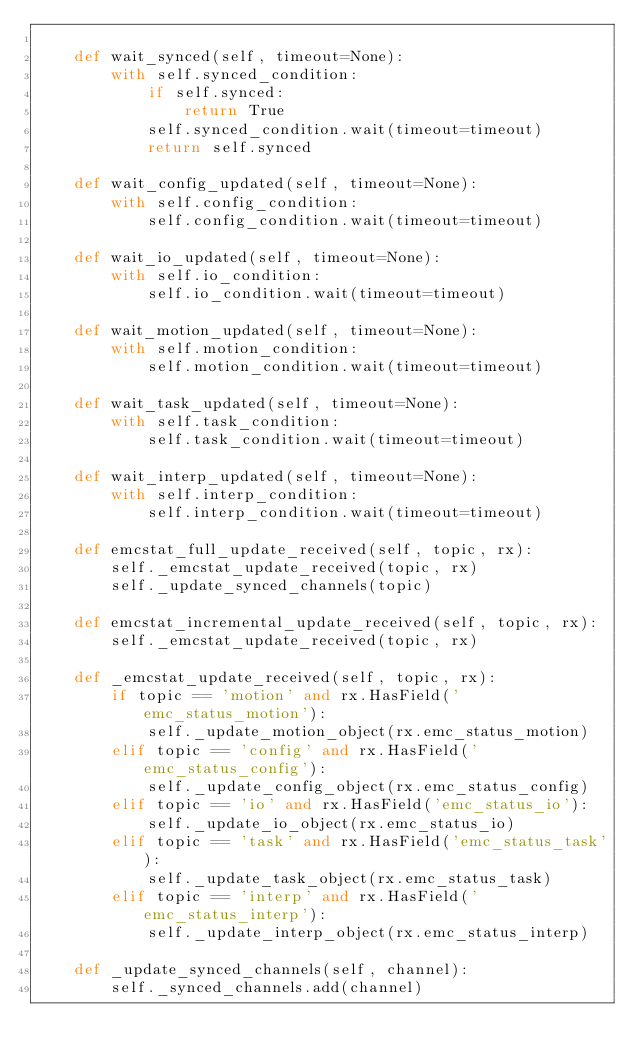Convert code to text. <code><loc_0><loc_0><loc_500><loc_500><_Python_>
    def wait_synced(self, timeout=None):
        with self.synced_condition:
            if self.synced:
                return True
            self.synced_condition.wait(timeout=timeout)
            return self.synced

    def wait_config_updated(self, timeout=None):
        with self.config_condition:
            self.config_condition.wait(timeout=timeout)

    def wait_io_updated(self, timeout=None):
        with self.io_condition:
            self.io_condition.wait(timeout=timeout)

    def wait_motion_updated(self, timeout=None):
        with self.motion_condition:
            self.motion_condition.wait(timeout=timeout)

    def wait_task_updated(self, timeout=None):
        with self.task_condition:
            self.task_condition.wait(timeout=timeout)

    def wait_interp_updated(self, timeout=None):
        with self.interp_condition:
            self.interp_condition.wait(timeout=timeout)

    def emcstat_full_update_received(self, topic, rx):
        self._emcstat_update_received(topic, rx)
        self._update_synced_channels(topic)

    def emcstat_incremental_update_received(self, topic, rx):
        self._emcstat_update_received(topic, rx)

    def _emcstat_update_received(self, topic, rx):
        if topic == 'motion' and rx.HasField('emc_status_motion'):
            self._update_motion_object(rx.emc_status_motion)
        elif topic == 'config' and rx.HasField('emc_status_config'):
            self._update_config_object(rx.emc_status_config)
        elif topic == 'io' and rx.HasField('emc_status_io'):
            self._update_io_object(rx.emc_status_io)
        elif topic == 'task' and rx.HasField('emc_status_task'):
            self._update_task_object(rx.emc_status_task)
        elif topic == 'interp' and rx.HasField('emc_status_interp'):
            self._update_interp_object(rx.emc_status_interp)

    def _update_synced_channels(self, channel):
        self._synced_channels.add(channel)</code> 